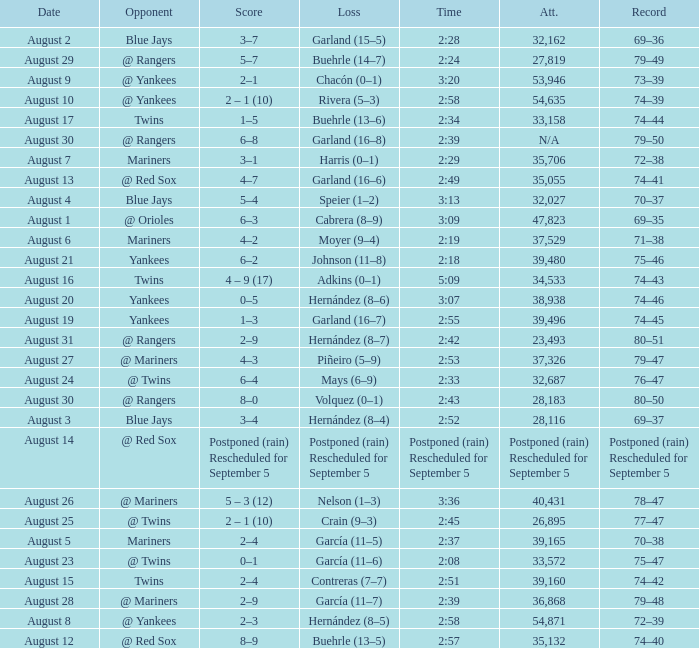Who lost on August 27? Piñeiro (5–9). 